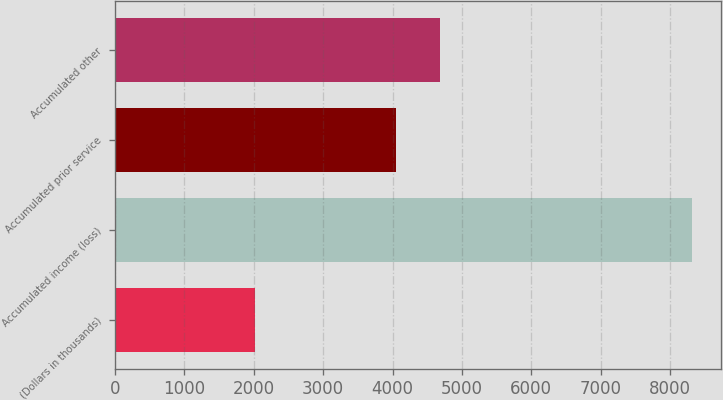Convert chart to OTSL. <chart><loc_0><loc_0><loc_500><loc_500><bar_chart><fcel>(Dollars in thousands)<fcel>Accumulated income (loss)<fcel>Accumulated prior service<fcel>Accumulated other<nl><fcel>2017<fcel>8317<fcel>4057<fcel>4687<nl></chart> 